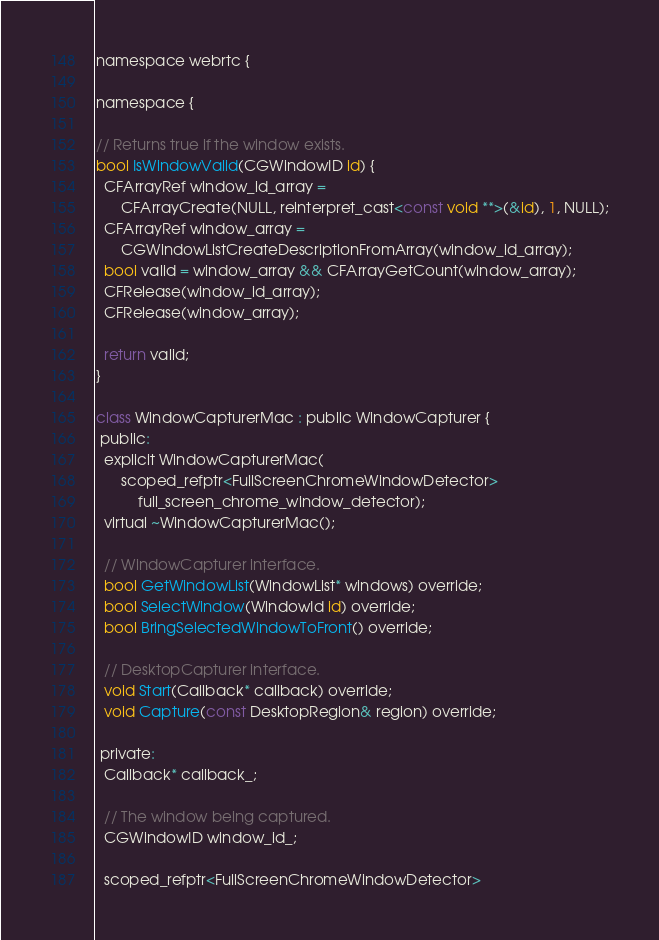Convert code to text. <code><loc_0><loc_0><loc_500><loc_500><_ObjectiveC_>
namespace webrtc {

namespace {

// Returns true if the window exists.
bool IsWindowValid(CGWindowID id) {
  CFArrayRef window_id_array =
      CFArrayCreate(NULL, reinterpret_cast<const void **>(&id), 1, NULL);
  CFArrayRef window_array =
      CGWindowListCreateDescriptionFromArray(window_id_array);
  bool valid = window_array && CFArrayGetCount(window_array);
  CFRelease(window_id_array);
  CFRelease(window_array);

  return valid;
}

class WindowCapturerMac : public WindowCapturer {
 public:
  explicit WindowCapturerMac(
      scoped_refptr<FullScreenChromeWindowDetector>
          full_screen_chrome_window_detector);
  virtual ~WindowCapturerMac();

  // WindowCapturer interface.
  bool GetWindowList(WindowList* windows) override;
  bool SelectWindow(WindowId id) override;
  bool BringSelectedWindowToFront() override;

  // DesktopCapturer interface.
  void Start(Callback* callback) override;
  void Capture(const DesktopRegion& region) override;

 private:
  Callback* callback_;

  // The window being captured.
  CGWindowID window_id_;

  scoped_refptr<FullScreenChromeWindowDetector></code> 